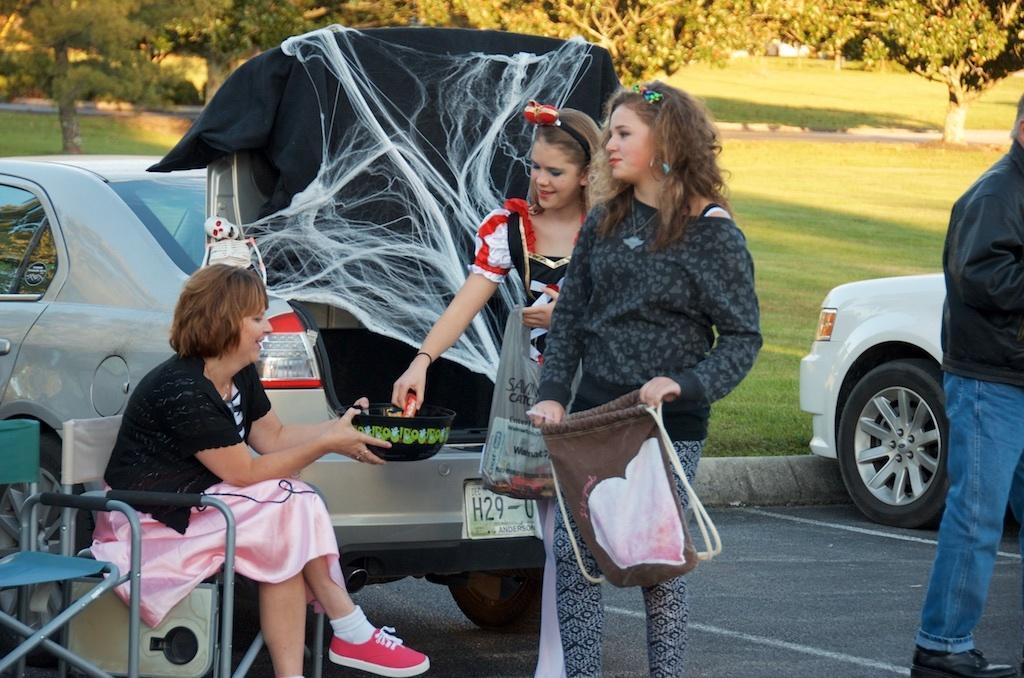Describe this image in one or two sentences. In the center of the image we can see two standing and holding bags. On the left there is a lady sitting and holding a bowl. There are chairs. On the left there is a man. In the background there are cars, tent and trees. 